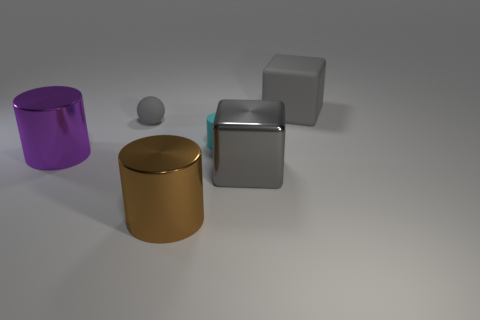What is the shape of the large gray object on the left side of the big thing behind the tiny matte cylinder? cube 